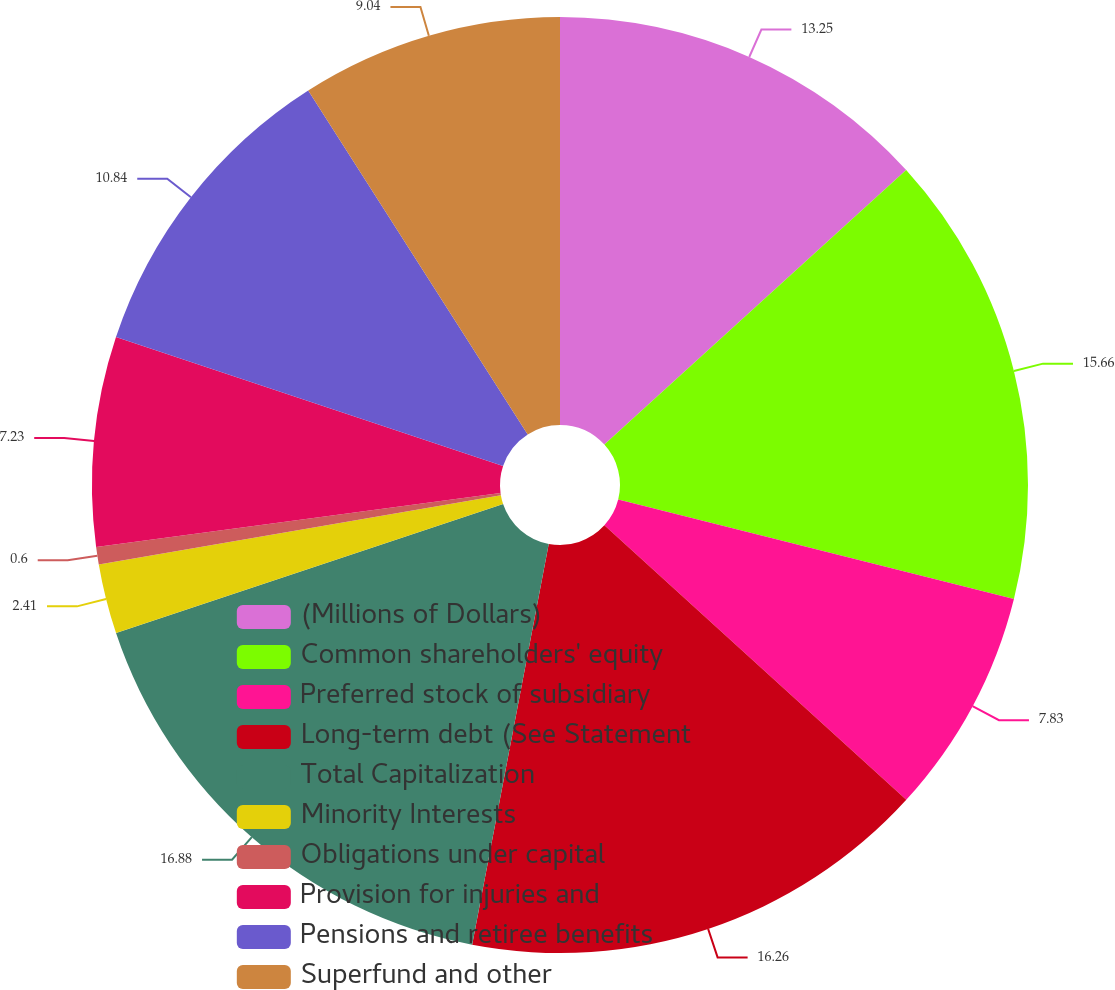<chart> <loc_0><loc_0><loc_500><loc_500><pie_chart><fcel>(Millions of Dollars)<fcel>Common shareholders' equity<fcel>Preferred stock of subsidiary<fcel>Long-term debt (See Statement<fcel>Total Capitalization<fcel>Minority Interests<fcel>Obligations under capital<fcel>Provision for injuries and<fcel>Pensions and retiree benefits<fcel>Superfund and other<nl><fcel>13.25%<fcel>15.66%<fcel>7.83%<fcel>16.26%<fcel>16.87%<fcel>2.41%<fcel>0.6%<fcel>7.23%<fcel>10.84%<fcel>9.04%<nl></chart> 